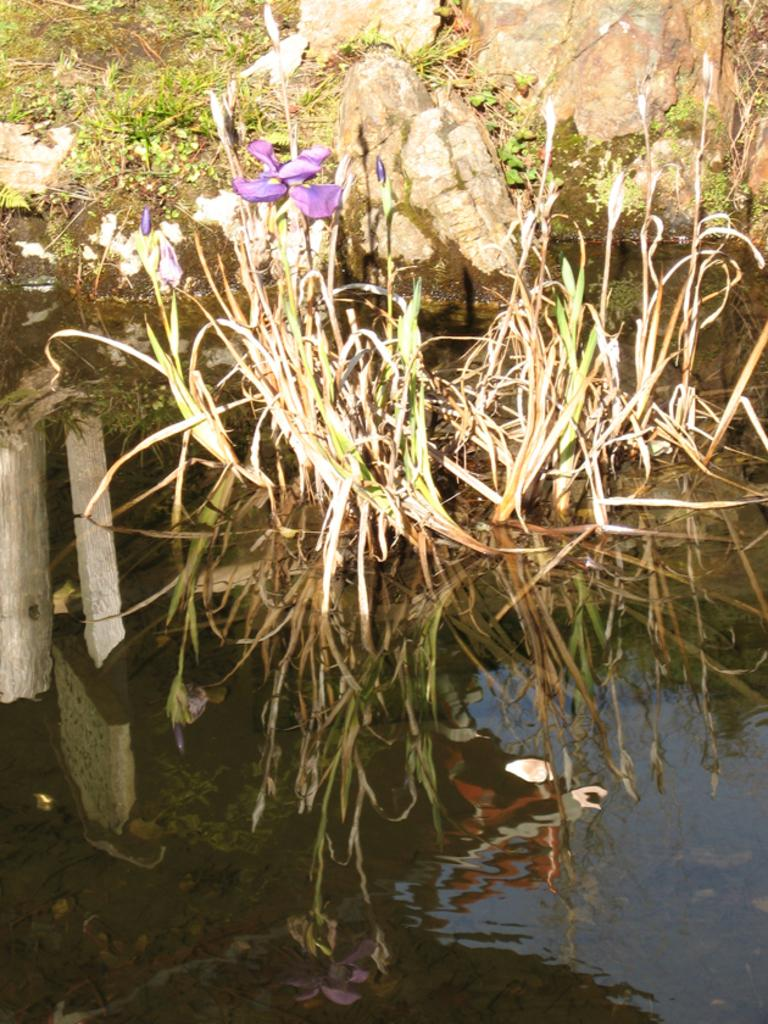What is the primary element in the image? There is water in the image. What types of vegetation can be seen in the image? There are plants and flowers in the image. What other objects are present in the image? There are stones and a wooden stick in the image. What can be seen in the background of the image? There is grass visible in the background of the image. What type of toothpaste is being used to clean the mask in the image? There is no mask or toothpaste present in the image. 